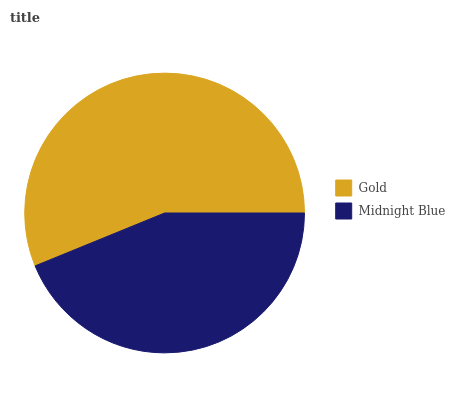Is Midnight Blue the minimum?
Answer yes or no. Yes. Is Gold the maximum?
Answer yes or no. Yes. Is Midnight Blue the maximum?
Answer yes or no. No. Is Gold greater than Midnight Blue?
Answer yes or no. Yes. Is Midnight Blue less than Gold?
Answer yes or no. Yes. Is Midnight Blue greater than Gold?
Answer yes or no. No. Is Gold less than Midnight Blue?
Answer yes or no. No. Is Gold the high median?
Answer yes or no. Yes. Is Midnight Blue the low median?
Answer yes or no. Yes. Is Midnight Blue the high median?
Answer yes or no. No. Is Gold the low median?
Answer yes or no. No. 